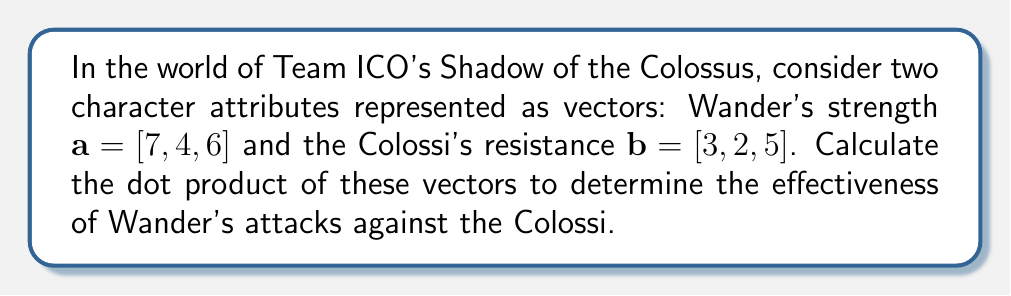Can you solve this math problem? To calculate the dot product of two vectors $\mathbf{a} = [a_1, a_2, a_3]$ and $\mathbf{b} = [b_1, b_2, b_3]$, we use the formula:

$$\mathbf{a} \cdot \mathbf{b} = a_1b_1 + a_2b_2 + a_3b_3$$

For the given vectors:
$\mathbf{a} = [7, 4, 6]$ (Wander's strength)
$\mathbf{b} = [3, 2, 5]$ (Colossi's resistance)

Let's compute each term:
1. $a_1b_1 = 7 \times 3 = 21$
2. $a_2b_2 = 4 \times 2 = 8$
3. $a_3b_3 = 6 \times 5 = 30$

Now, sum up these terms:

$$\mathbf{a} \cdot \mathbf{b} = 21 + 8 + 30 = 59$$

The dot product represents the effectiveness of Wander's attacks against the Colossi's resistance.
Answer: $59$ 